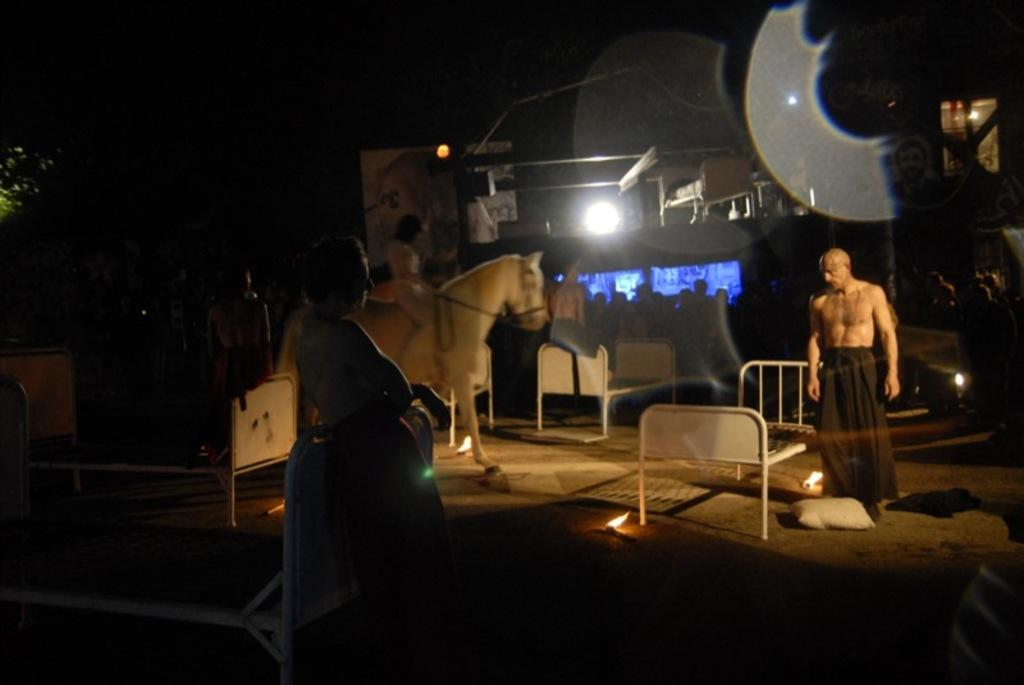What activity is taking place in the image? There is a shooting sport in the image. Who is involved in the activity? There are people in the image. What type of furniture is present in the image? There are iron beds in the image. What can be seen providing illumination in the image? There are lights in the image. What objects are related to the activity or setting? There are instruments around in the image. What type of bushes can be seen growing near the shooting range in the image? There are no bushes visible in the image; it primarily features a shooting sport, people, iron beds, lights, and instruments. 